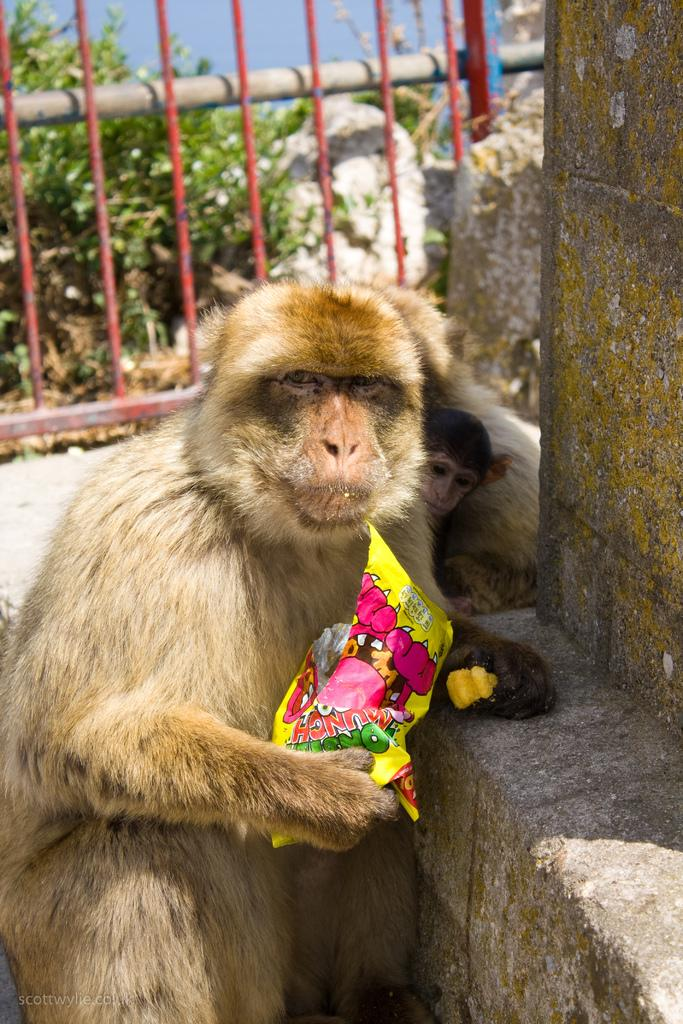What animal is present in the image? There is a monkey in the image. What is the monkey holding in the image? The monkey is holding a packet. What type of barrier can be seen in the image? There is fencing in the image. What type of vegetation is visible in the image? There are plants visible in the image. What date is marked on the calendar in the image? There is no calendar present in the image. What type of box is visible in the image? There is no box present in the image. 